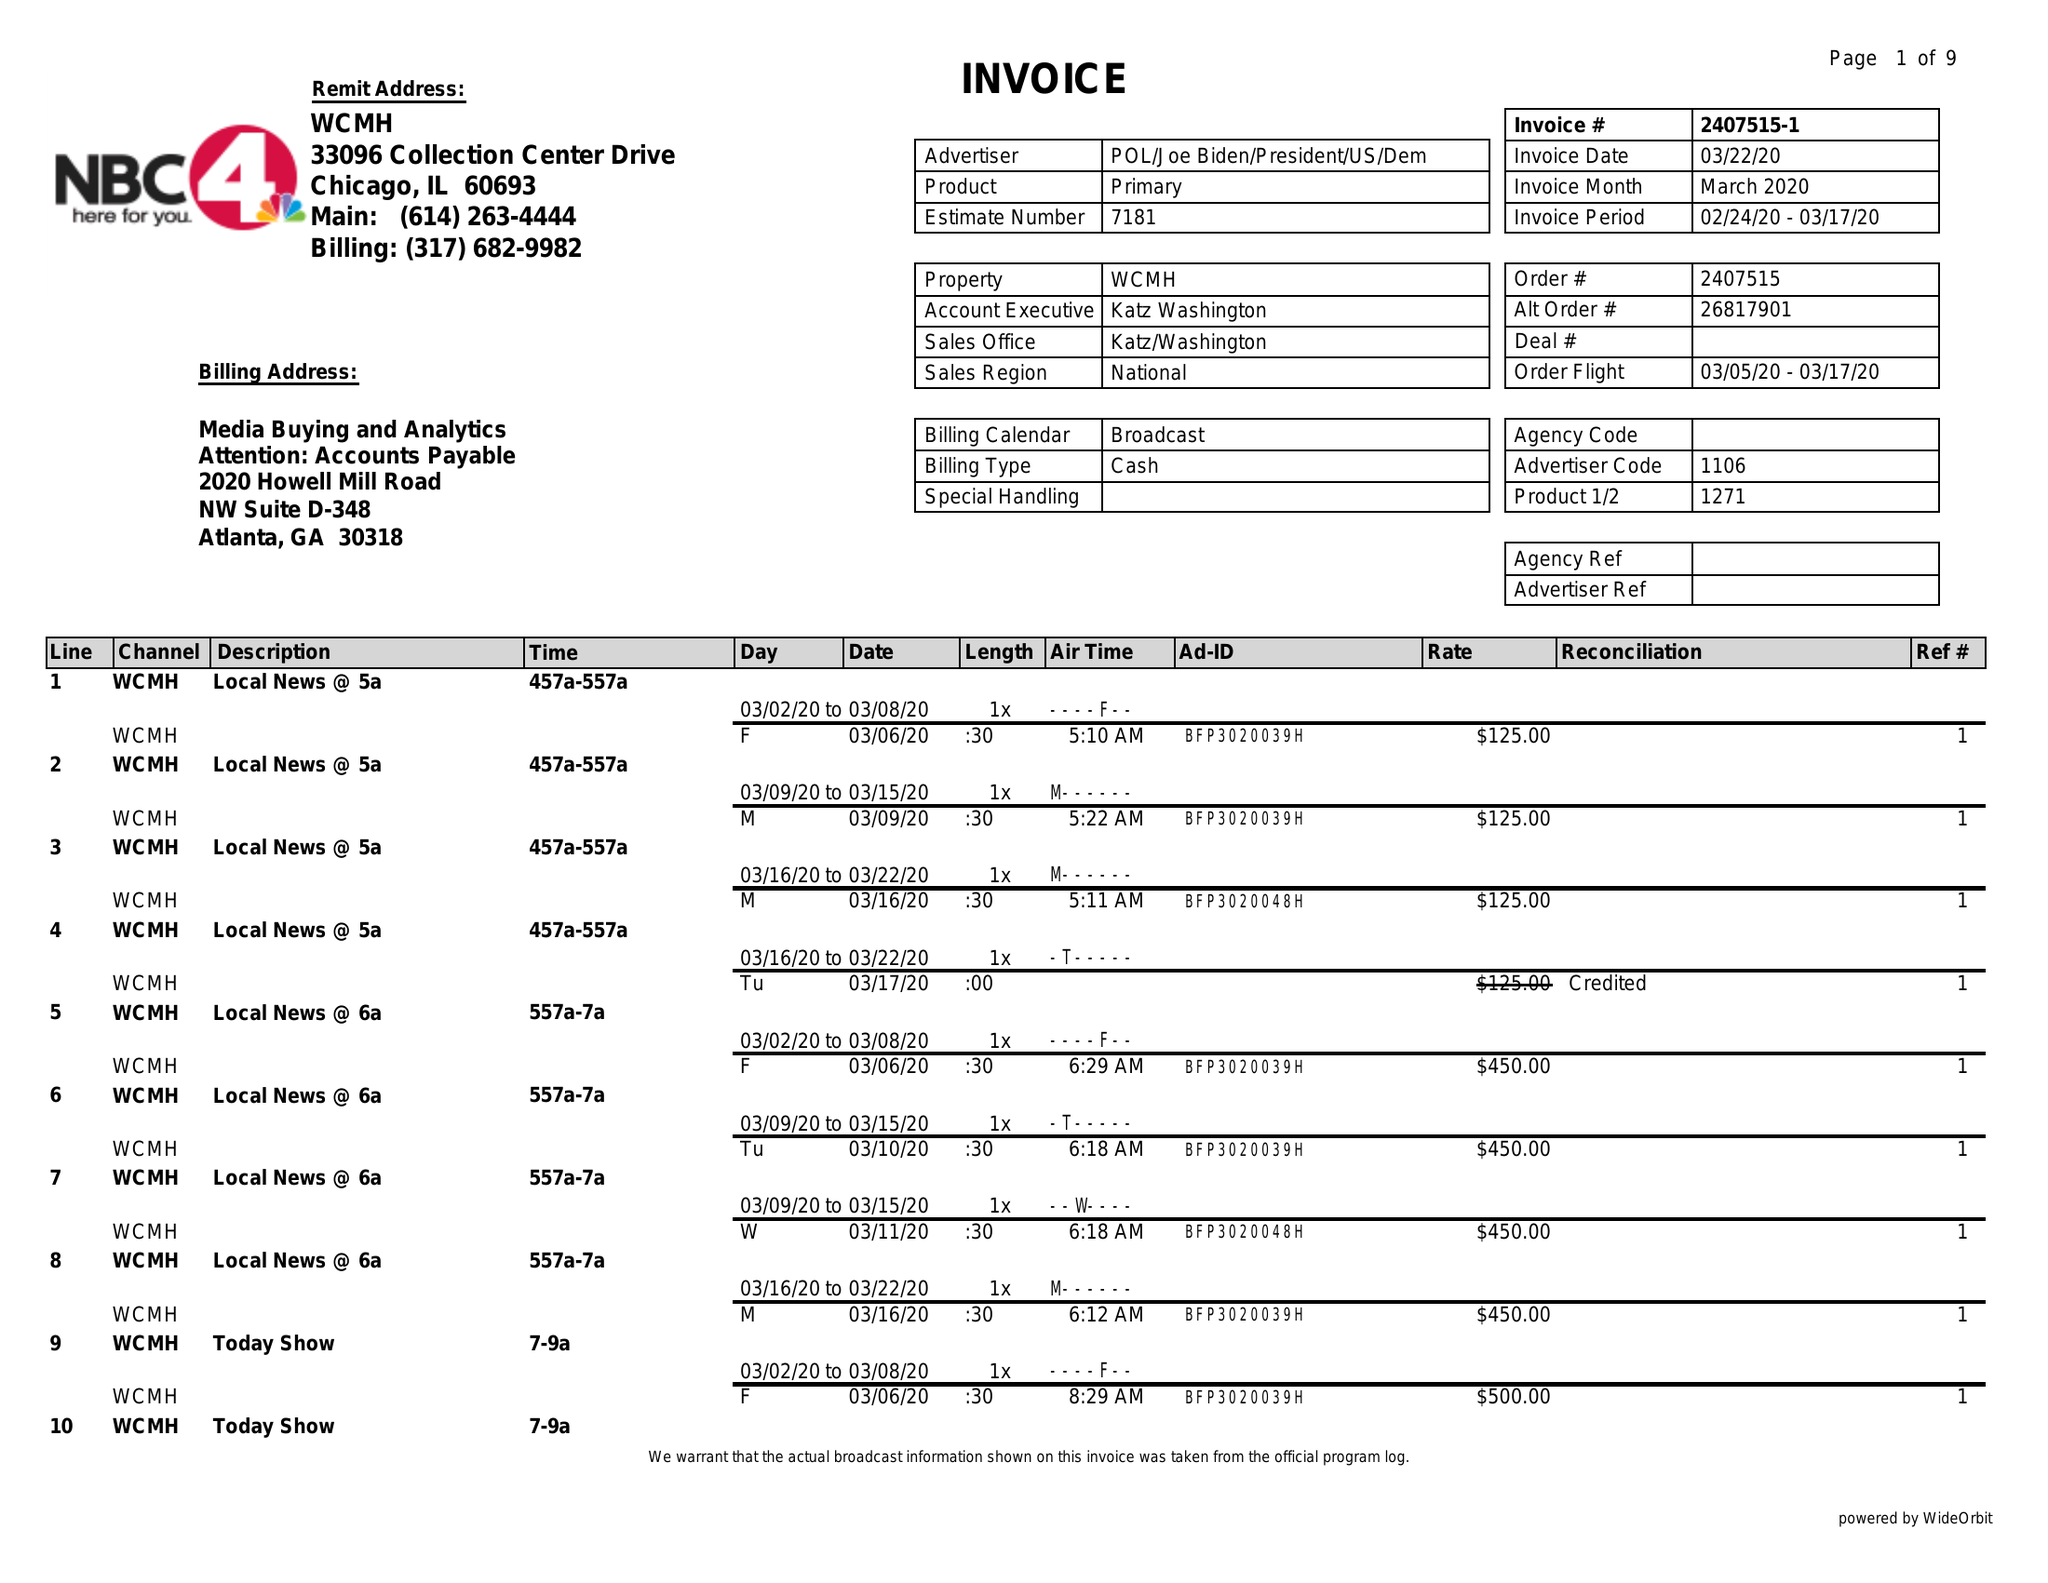What is the value for the flight_from?
Answer the question using a single word or phrase. 03/05/20 